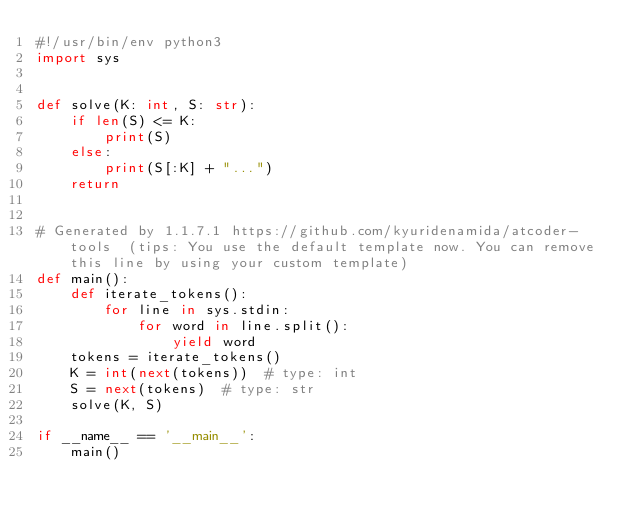<code> <loc_0><loc_0><loc_500><loc_500><_Python_>#!/usr/bin/env python3
import sys


def solve(K: int, S: str):
    if len(S) <= K:
        print(S)
    else:
        print(S[:K] + "...")
    return


# Generated by 1.1.7.1 https://github.com/kyuridenamida/atcoder-tools  (tips: You use the default template now. You can remove this line by using your custom template)
def main():
    def iterate_tokens():
        for line in sys.stdin:
            for word in line.split():
                yield word
    tokens = iterate_tokens()
    K = int(next(tokens))  # type: int
    S = next(tokens)  # type: str
    solve(K, S)

if __name__ == '__main__':
    main()
</code> 